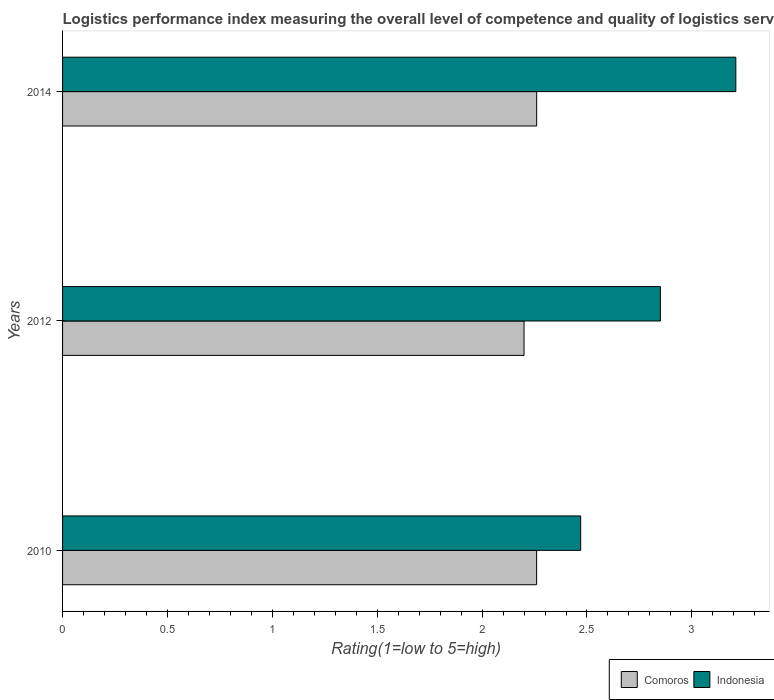How many different coloured bars are there?
Provide a short and direct response. 2. How many bars are there on the 2nd tick from the top?
Give a very brief answer. 2. In how many cases, is the number of bars for a given year not equal to the number of legend labels?
Your response must be concise. 0. What is the Logistic performance index in Indonesia in 2012?
Provide a short and direct response. 2.85. Across all years, what is the maximum Logistic performance index in Comoros?
Ensure brevity in your answer.  2.26. Across all years, what is the minimum Logistic performance index in Indonesia?
Provide a short and direct response. 2.47. In which year was the Logistic performance index in Indonesia minimum?
Your response must be concise. 2010. What is the total Logistic performance index in Indonesia in the graph?
Offer a very short reply. 8.53. What is the difference between the Logistic performance index in Comoros in 2010 and that in 2014?
Your answer should be very brief. -0. What is the difference between the Logistic performance index in Indonesia in 2010 and the Logistic performance index in Comoros in 2014?
Make the answer very short. 0.21. What is the average Logistic performance index in Comoros per year?
Keep it short and to the point. 2.24. In the year 2014, what is the difference between the Logistic performance index in Indonesia and Logistic performance index in Comoros?
Provide a short and direct response. 0.95. What is the ratio of the Logistic performance index in Indonesia in 2010 to that in 2014?
Your answer should be compact. 0.77. Is the Logistic performance index in Comoros in 2010 less than that in 2012?
Make the answer very short. No. Is the difference between the Logistic performance index in Indonesia in 2010 and 2012 greater than the difference between the Logistic performance index in Comoros in 2010 and 2012?
Your answer should be compact. No. What is the difference between the highest and the second highest Logistic performance index in Indonesia?
Give a very brief answer. 0.36. What is the difference between the highest and the lowest Logistic performance index in Indonesia?
Ensure brevity in your answer.  0.74. In how many years, is the Logistic performance index in Indonesia greater than the average Logistic performance index in Indonesia taken over all years?
Give a very brief answer. 2. Is the sum of the Logistic performance index in Indonesia in 2012 and 2014 greater than the maximum Logistic performance index in Comoros across all years?
Provide a short and direct response. Yes. What does the 2nd bar from the top in 2010 represents?
Provide a succinct answer. Comoros. How many bars are there?
Your response must be concise. 6. Are all the bars in the graph horizontal?
Provide a succinct answer. Yes. How many years are there in the graph?
Ensure brevity in your answer.  3. What is the difference between two consecutive major ticks on the X-axis?
Provide a short and direct response. 0.5. Are the values on the major ticks of X-axis written in scientific E-notation?
Offer a terse response. No. Does the graph contain grids?
Make the answer very short. No. How many legend labels are there?
Provide a succinct answer. 2. How are the legend labels stacked?
Offer a terse response. Horizontal. What is the title of the graph?
Offer a very short reply. Logistics performance index measuring the overall level of competence and quality of logistics services. What is the label or title of the X-axis?
Offer a terse response. Rating(1=low to 5=high). What is the label or title of the Y-axis?
Offer a terse response. Years. What is the Rating(1=low to 5=high) in Comoros in 2010?
Provide a short and direct response. 2.26. What is the Rating(1=low to 5=high) in Indonesia in 2010?
Offer a terse response. 2.47. What is the Rating(1=low to 5=high) in Comoros in 2012?
Your answer should be very brief. 2.2. What is the Rating(1=low to 5=high) in Indonesia in 2012?
Make the answer very short. 2.85. What is the Rating(1=low to 5=high) in Comoros in 2014?
Your response must be concise. 2.26. What is the Rating(1=low to 5=high) of Indonesia in 2014?
Keep it short and to the point. 3.21. Across all years, what is the maximum Rating(1=low to 5=high) of Comoros?
Ensure brevity in your answer.  2.26. Across all years, what is the maximum Rating(1=low to 5=high) of Indonesia?
Offer a terse response. 3.21. Across all years, what is the minimum Rating(1=low to 5=high) of Comoros?
Give a very brief answer. 2.2. Across all years, what is the minimum Rating(1=low to 5=high) in Indonesia?
Provide a short and direct response. 2.47. What is the total Rating(1=low to 5=high) of Comoros in the graph?
Provide a succinct answer. 6.72. What is the total Rating(1=low to 5=high) in Indonesia in the graph?
Your answer should be very brief. 8.53. What is the difference between the Rating(1=low to 5=high) of Indonesia in 2010 and that in 2012?
Your answer should be compact. -0.38. What is the difference between the Rating(1=low to 5=high) in Comoros in 2010 and that in 2014?
Give a very brief answer. -0. What is the difference between the Rating(1=low to 5=high) in Indonesia in 2010 and that in 2014?
Keep it short and to the point. -0.74. What is the difference between the Rating(1=low to 5=high) of Comoros in 2012 and that in 2014?
Offer a terse response. -0.06. What is the difference between the Rating(1=low to 5=high) of Indonesia in 2012 and that in 2014?
Make the answer very short. -0.36. What is the difference between the Rating(1=low to 5=high) in Comoros in 2010 and the Rating(1=low to 5=high) in Indonesia in 2012?
Keep it short and to the point. -0.59. What is the difference between the Rating(1=low to 5=high) in Comoros in 2010 and the Rating(1=low to 5=high) in Indonesia in 2014?
Your answer should be compact. -0.95. What is the difference between the Rating(1=low to 5=high) in Comoros in 2012 and the Rating(1=low to 5=high) in Indonesia in 2014?
Provide a short and direct response. -1.01. What is the average Rating(1=low to 5=high) in Comoros per year?
Offer a very short reply. 2.24. What is the average Rating(1=low to 5=high) in Indonesia per year?
Your answer should be very brief. 2.84. In the year 2010, what is the difference between the Rating(1=low to 5=high) of Comoros and Rating(1=low to 5=high) of Indonesia?
Give a very brief answer. -0.21. In the year 2012, what is the difference between the Rating(1=low to 5=high) in Comoros and Rating(1=low to 5=high) in Indonesia?
Make the answer very short. -0.65. In the year 2014, what is the difference between the Rating(1=low to 5=high) in Comoros and Rating(1=low to 5=high) in Indonesia?
Give a very brief answer. -0.95. What is the ratio of the Rating(1=low to 5=high) of Comoros in 2010 to that in 2012?
Your response must be concise. 1.03. What is the ratio of the Rating(1=low to 5=high) of Indonesia in 2010 to that in 2012?
Keep it short and to the point. 0.87. What is the ratio of the Rating(1=low to 5=high) in Indonesia in 2010 to that in 2014?
Keep it short and to the point. 0.77. What is the ratio of the Rating(1=low to 5=high) of Comoros in 2012 to that in 2014?
Your answer should be very brief. 0.97. What is the ratio of the Rating(1=low to 5=high) of Indonesia in 2012 to that in 2014?
Provide a succinct answer. 0.89. What is the difference between the highest and the second highest Rating(1=low to 5=high) in Indonesia?
Your answer should be compact. 0.36. What is the difference between the highest and the lowest Rating(1=low to 5=high) of Comoros?
Make the answer very short. 0.06. What is the difference between the highest and the lowest Rating(1=low to 5=high) of Indonesia?
Provide a succinct answer. 0.74. 